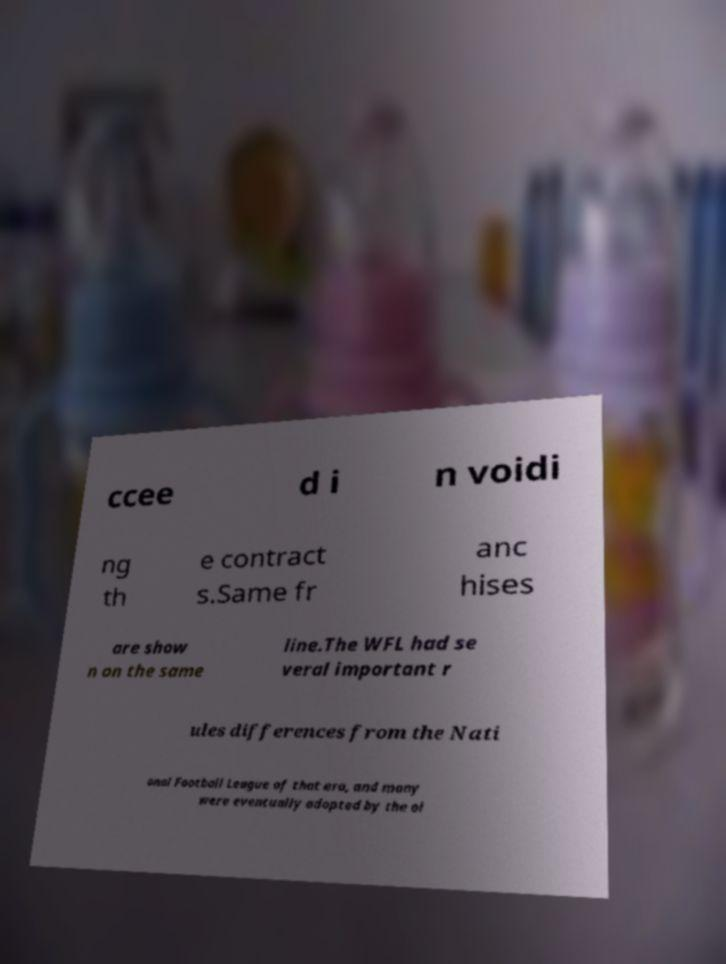Can you read and provide the text displayed in the image?This photo seems to have some interesting text. Can you extract and type it out for me? ccee d i n voidi ng th e contract s.Same fr anc hises are show n on the same line.The WFL had se veral important r ules differences from the Nati onal Football League of that era, and many were eventually adopted by the ol 